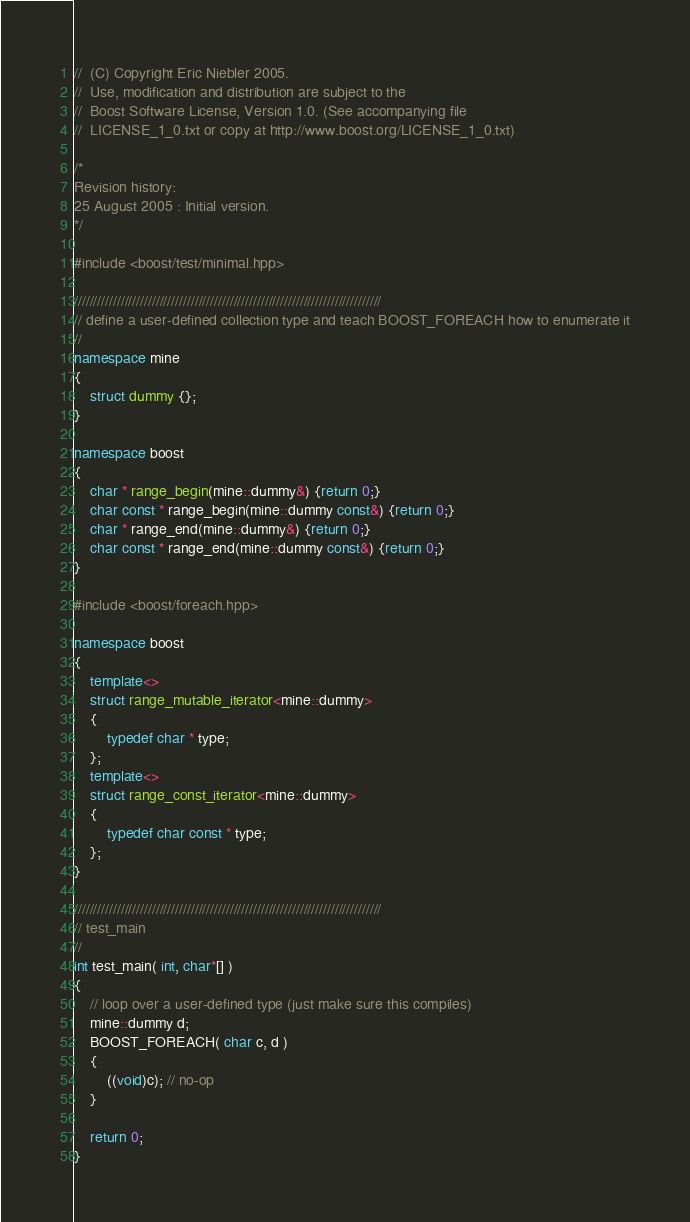Convert code to text. <code><loc_0><loc_0><loc_500><loc_500><_C++_>//  (C) Copyright Eric Niebler 2005.
//  Use, modification and distribution are subject to the
//  Boost Software License, Version 1.0. (See accompanying file
//  LICENSE_1_0.txt or copy at http://www.boost.org/LICENSE_1_0.txt)

/*
Revision history:
25 August 2005 : Initial version.
*/

#include <boost/test/minimal.hpp>

///////////////////////////////////////////////////////////////////////////////
// define a user-defined collection type and teach BOOST_FOREACH how to enumerate it
//
namespace mine
{
    struct dummy {};
}

namespace boost
{
    char * range_begin(mine::dummy&) {return 0;}
    char const * range_begin(mine::dummy const&) {return 0;}
    char * range_end(mine::dummy&) {return 0;}
    char const * range_end(mine::dummy const&) {return 0;}
}

#include <boost/foreach.hpp>

namespace boost
{
    template<>
    struct range_mutable_iterator<mine::dummy>
    {
        typedef char * type;
    };
    template<>
    struct range_const_iterator<mine::dummy>
    {
        typedef char const * type;
    };
}

///////////////////////////////////////////////////////////////////////////////
// test_main
//   
int test_main( int, char*[] )
{
    // loop over a user-defined type (just make sure this compiles)
    mine::dummy d;
    BOOST_FOREACH( char c, d )
    {
        ((void)c); // no-op
    }

    return 0;
}
</code> 